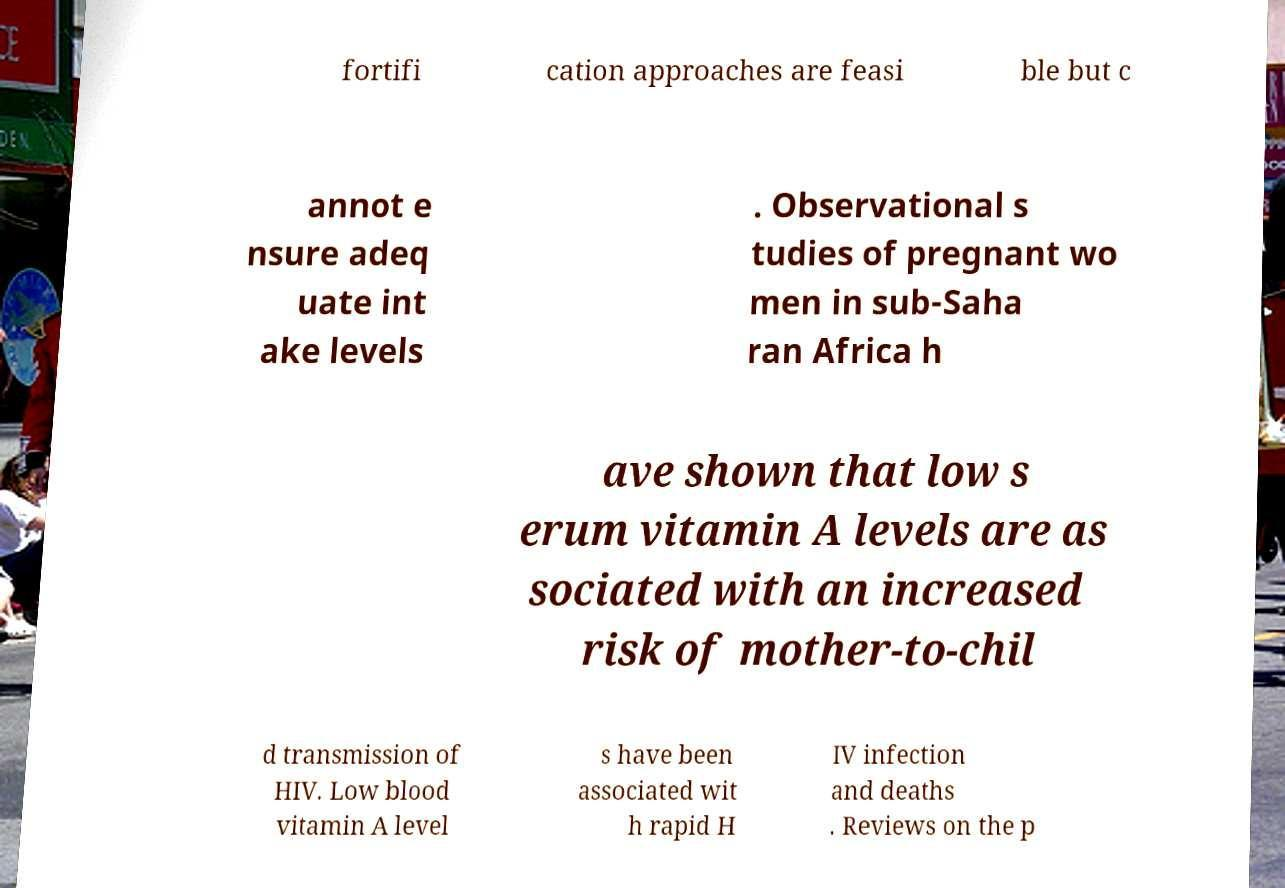There's text embedded in this image that I need extracted. Can you transcribe it verbatim? fortifi cation approaches are feasi ble but c annot e nsure adeq uate int ake levels . Observational s tudies of pregnant wo men in sub-Saha ran Africa h ave shown that low s erum vitamin A levels are as sociated with an increased risk of mother-to-chil d transmission of HIV. Low blood vitamin A level s have been associated wit h rapid H IV infection and deaths . Reviews on the p 